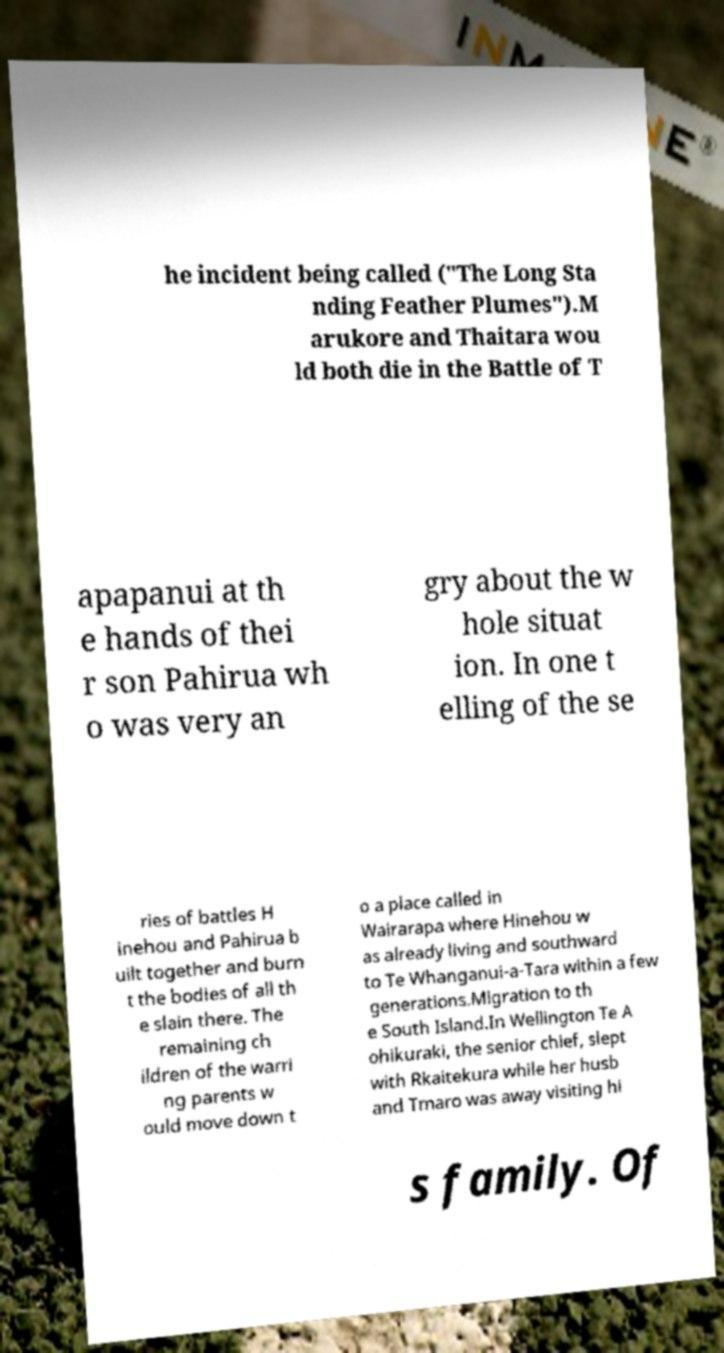Please read and relay the text visible in this image. What does it say? he incident being called ("The Long Sta nding Feather Plumes").M arukore and Thaitara wou ld both die in the Battle of T apapanui at th e hands of thei r son Pahirua wh o was very an gry about the w hole situat ion. In one t elling of the se ries of battles H inehou and Pahirua b uilt together and burn t the bodies of all th e slain there. The remaining ch ildren of the warri ng parents w ould move down t o a place called in Wairarapa where Hinehou w as already living and southward to Te Whanganui-a-Tara within a few generations.Migration to th e South Island.In Wellington Te A ohikuraki, the senior chief, slept with Rkaitekura while her husb and Tmaro was away visiting hi s family. Of 